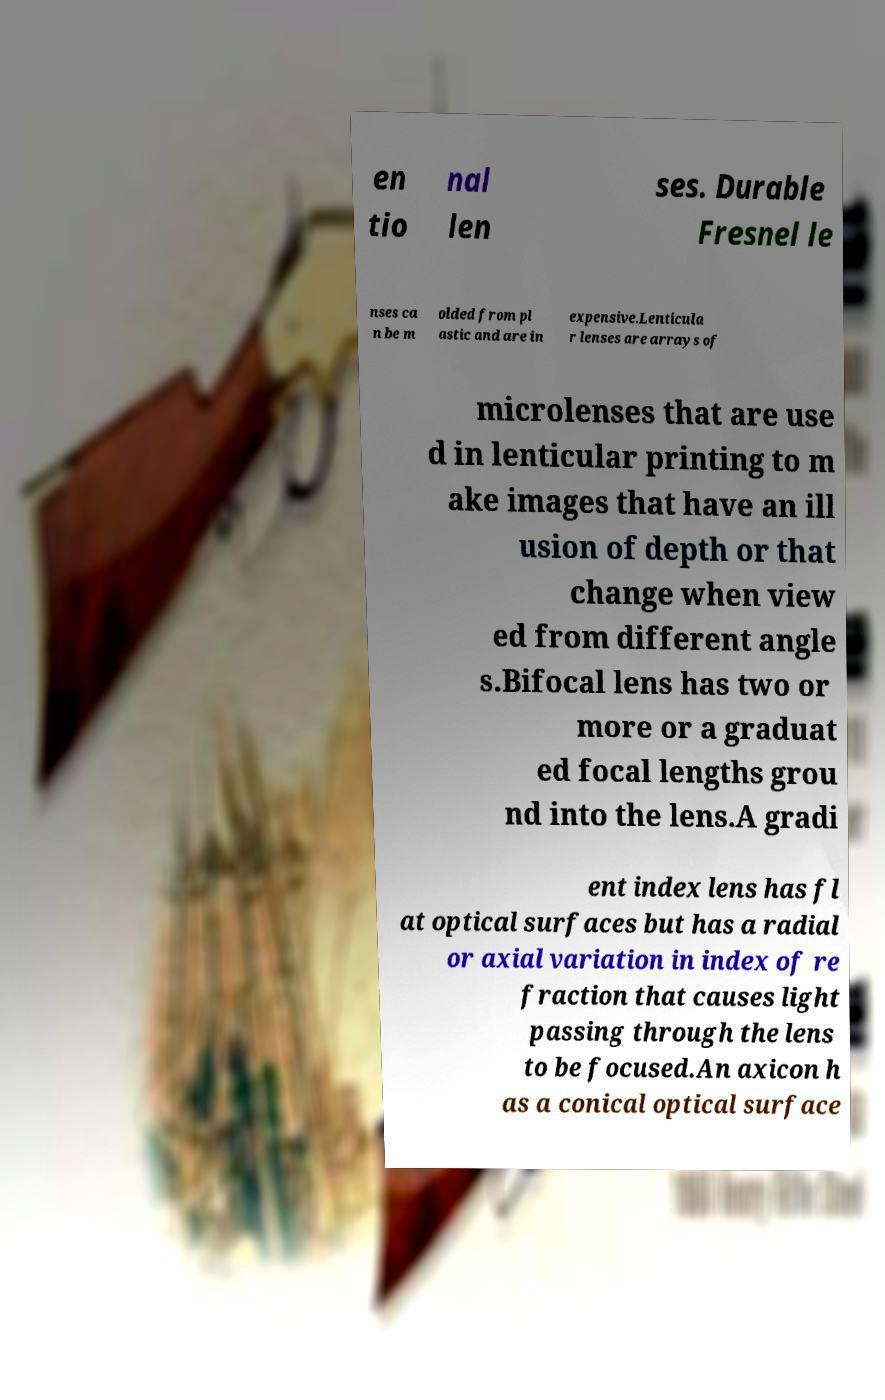What messages or text are displayed in this image? I need them in a readable, typed format. en tio nal len ses. Durable Fresnel le nses ca n be m olded from pl astic and are in expensive.Lenticula r lenses are arrays of microlenses that are use d in lenticular printing to m ake images that have an ill usion of depth or that change when view ed from different angle s.Bifocal lens has two or more or a graduat ed focal lengths grou nd into the lens.A gradi ent index lens has fl at optical surfaces but has a radial or axial variation in index of re fraction that causes light passing through the lens to be focused.An axicon h as a conical optical surface 